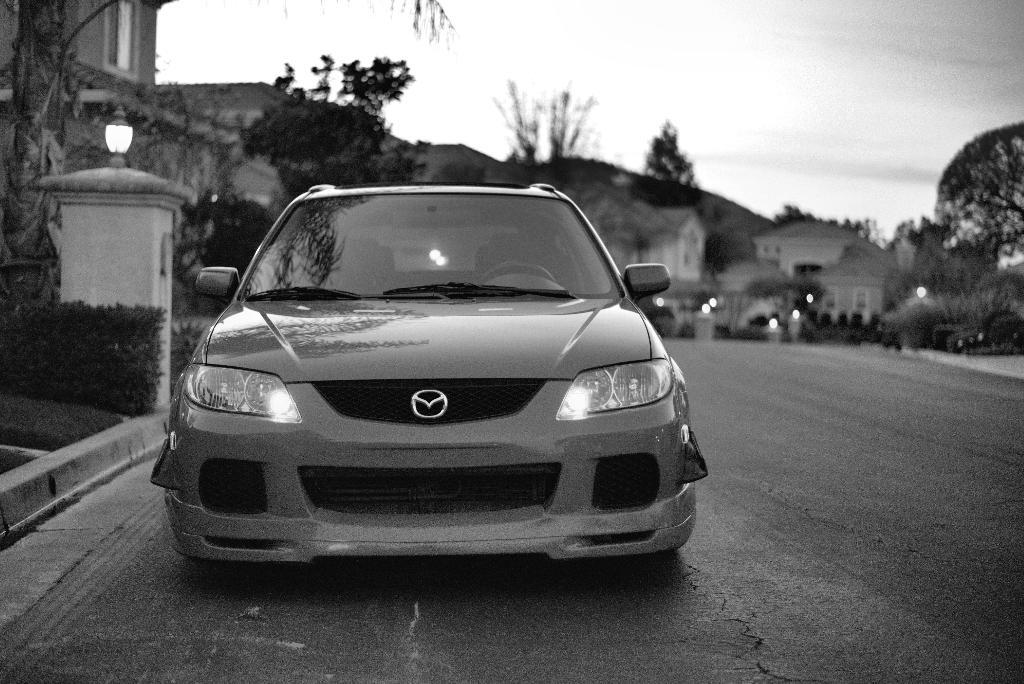What is the main subject of the image? There is a car in the image. Where is the car located? The car is on the road. What can be seen in the background of the image? There are buildings, trees, lights, and the sky visible in the background of the image. What type of harmony is being played by the car in the image? There is no harmony being played by the car in the image, as cars do not produce music. 